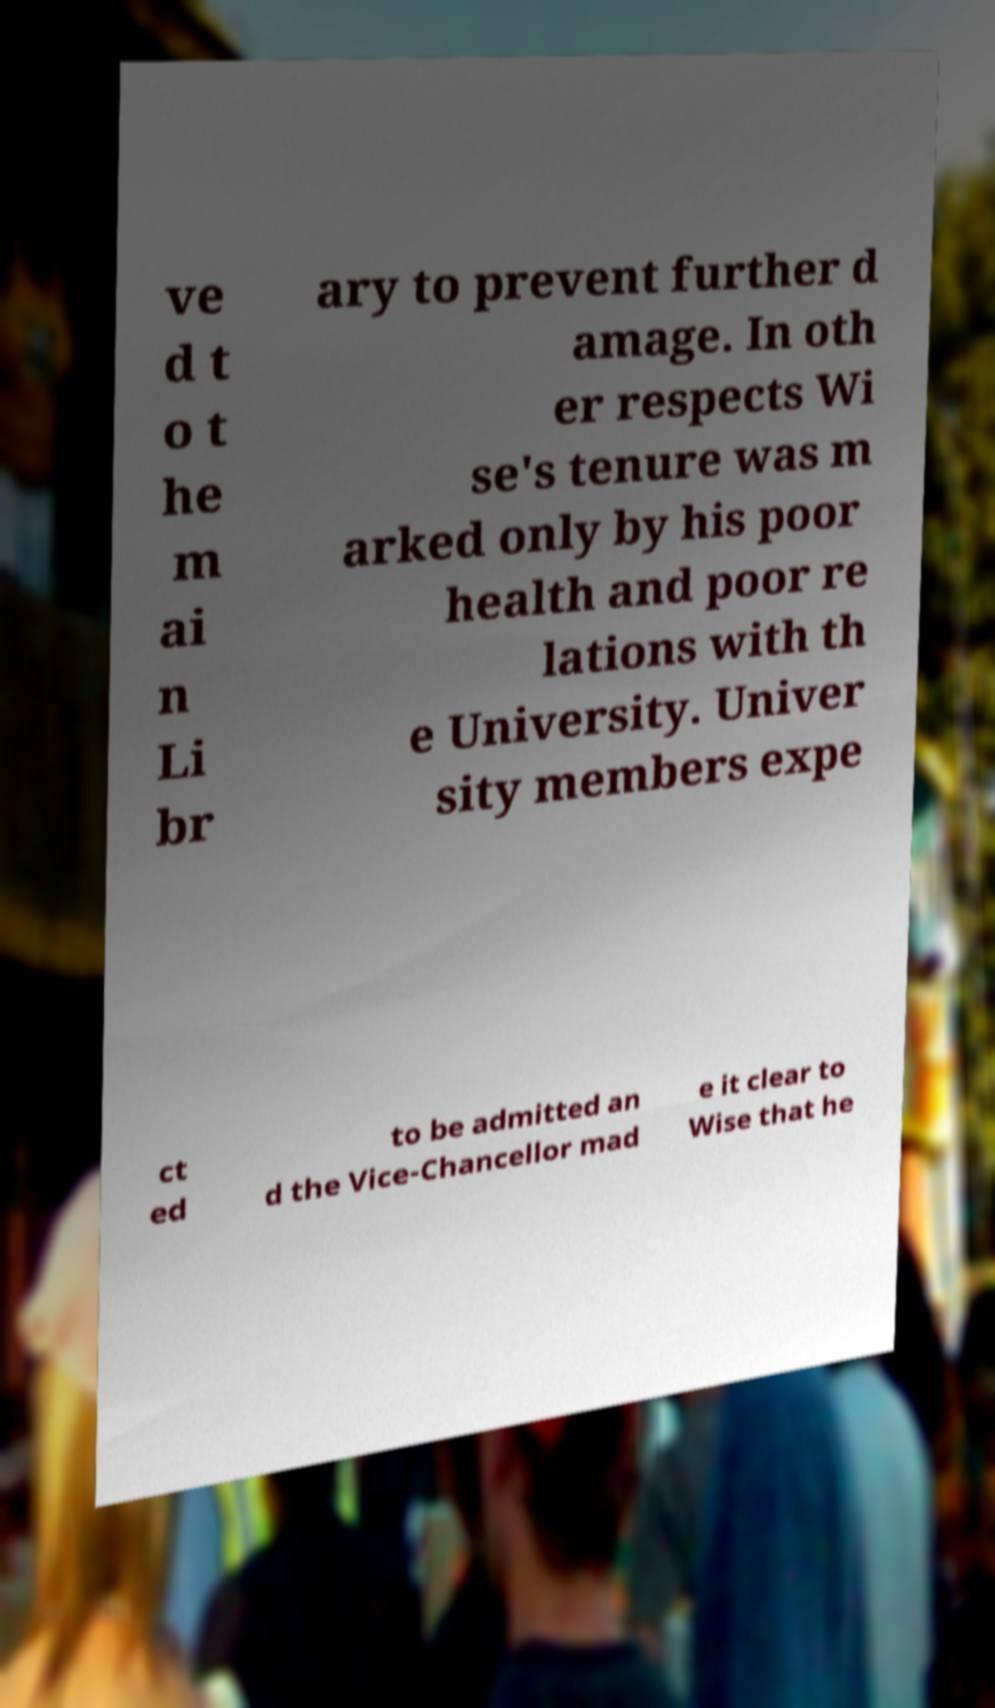For documentation purposes, I need the text within this image transcribed. Could you provide that? ve d t o t he m ai n Li br ary to prevent further d amage. In oth er respects Wi se's tenure was m arked only by his poor health and poor re lations with th e University. Univer sity members expe ct ed to be admitted an d the Vice-Chancellor mad e it clear to Wise that he 